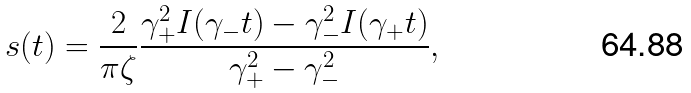Convert formula to latex. <formula><loc_0><loc_0><loc_500><loc_500>s ( t ) = \frac { 2 } { \pi \zeta } \frac { \gamma _ { + } ^ { 2 } I ( \gamma _ { - } t ) - \gamma _ { - } ^ { 2 } I ( \gamma _ { + } t ) } { \gamma _ { + } ^ { 2 } - \gamma _ { - } ^ { 2 } } ,</formula> 